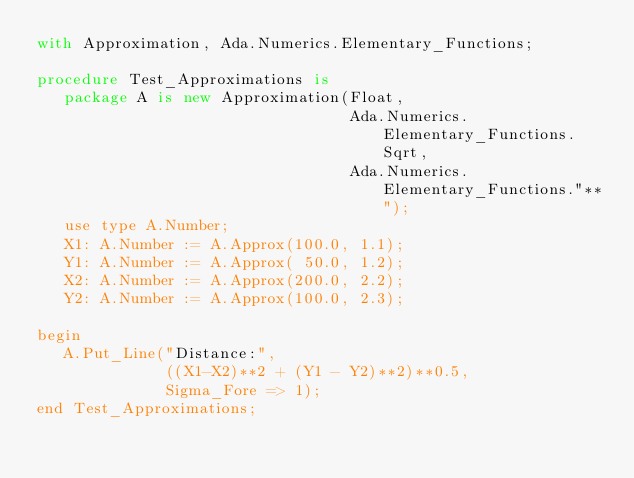Convert code to text. <code><loc_0><loc_0><loc_500><loc_500><_Ada_>with Approximation, Ada.Numerics.Elementary_Functions;

procedure Test_Approximations is
   package A is new Approximation(Float,
                                  Ada.Numerics.Elementary_Functions.Sqrt,
                                  Ada.Numerics.Elementary_Functions."**");
   use type A.Number;
   X1: A.Number := A.Approx(100.0, 1.1);
   Y1: A.Number := A.Approx( 50.0, 1.2);
   X2: A.Number := A.Approx(200.0, 2.2);
   Y2: A.Number := A.Approx(100.0, 2.3);

begin
   A.Put_Line("Distance:",
              ((X1-X2)**2 + (Y1 - Y2)**2)**0.5,
              Sigma_Fore => 1);
end Test_Approximations;
</code> 